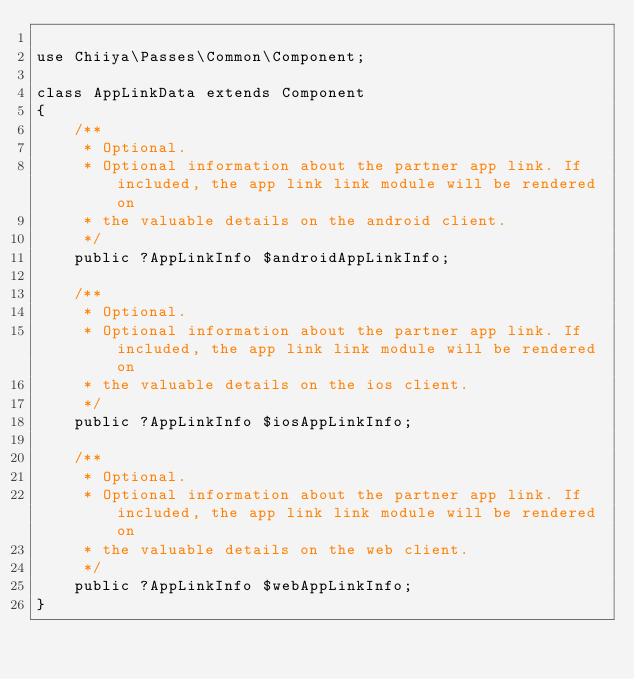Convert code to text. <code><loc_0><loc_0><loc_500><loc_500><_PHP_>
use Chiiya\Passes\Common\Component;

class AppLinkData extends Component
{
    /**
     * Optional.
     * Optional information about the partner app link. If included, the app link link module will be rendered on
     * the valuable details on the android client.
     */
    public ?AppLinkInfo $androidAppLinkInfo;

    /**
     * Optional.
     * Optional information about the partner app link. If included, the app link link module will be rendered on
     * the valuable details on the ios client.
     */
    public ?AppLinkInfo $iosAppLinkInfo;

    /**
     * Optional.
     * Optional information about the partner app link. If included, the app link link module will be rendered on
     * the valuable details on the web client.
     */
    public ?AppLinkInfo $webAppLinkInfo;
}
</code> 